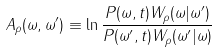<formula> <loc_0><loc_0><loc_500><loc_500>A _ { \rho } ( \omega , \omega ^ { \prime } ) \equiv \ln \frac { P ( \omega , t ) W _ { \rho } ( \omega | \omega ^ { \prime } ) } { P ( \omega ^ { \prime } , t ) W _ { \rho } ( \omega ^ { \prime } | \omega ) }</formula> 